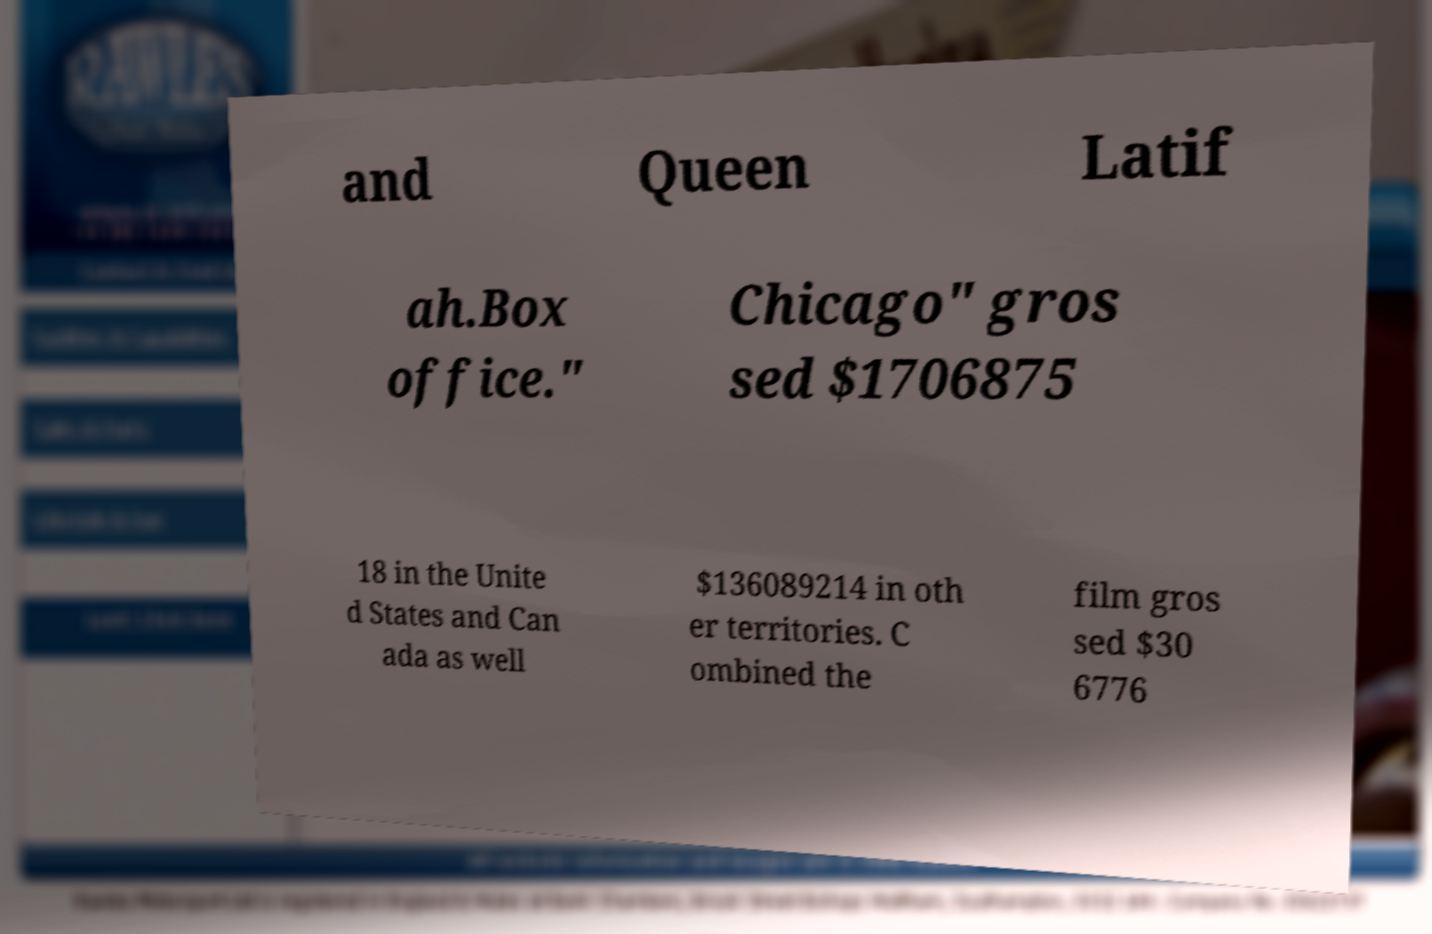What messages or text are displayed in this image? I need them in a readable, typed format. and Queen Latif ah.Box office." Chicago" gros sed $1706875 18 in the Unite d States and Can ada as well $136089214 in oth er territories. C ombined the film gros sed $30 6776 